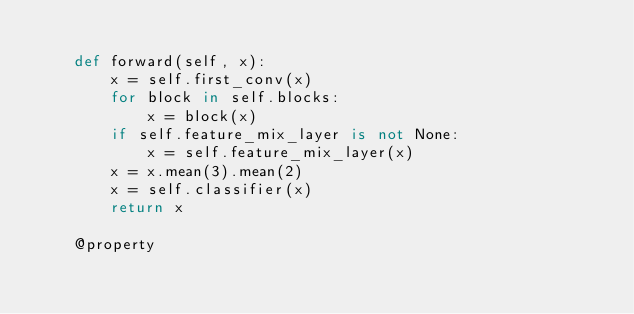<code> <loc_0><loc_0><loc_500><loc_500><_Python_>
    def forward(self, x):
        x = self.first_conv(x)
        for block in self.blocks:
            x = block(x)
        if self.feature_mix_layer is not None:
            x = self.feature_mix_layer(x)
        x = x.mean(3).mean(2)
        x = self.classifier(x)
        return x

    @property</code> 